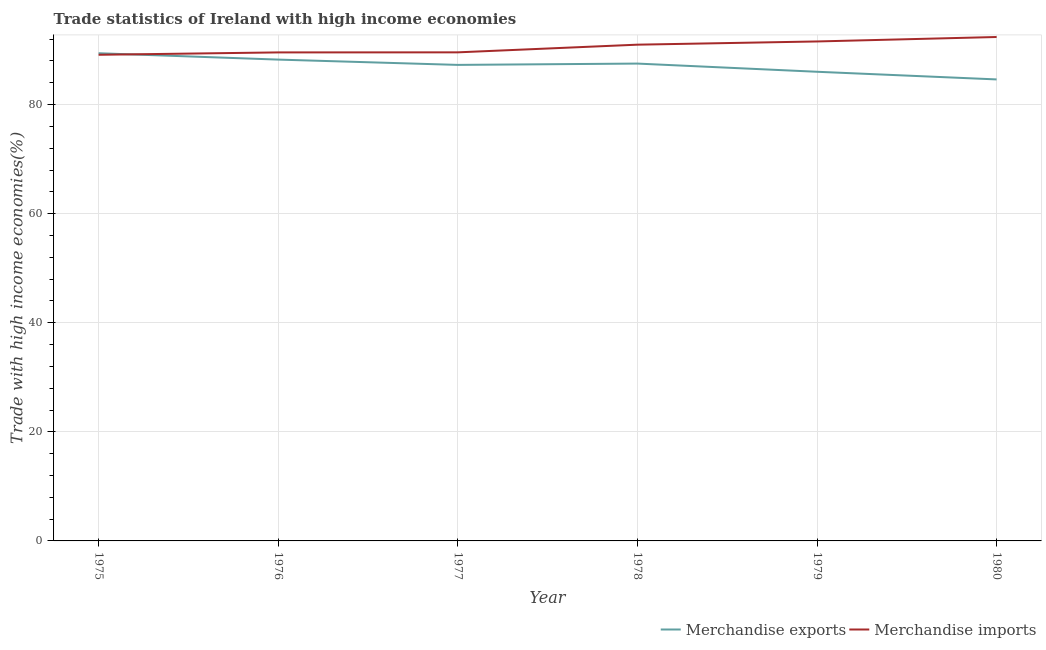How many different coloured lines are there?
Provide a short and direct response. 2. Is the number of lines equal to the number of legend labels?
Provide a succinct answer. Yes. What is the merchandise exports in 1975?
Keep it short and to the point. 89.42. Across all years, what is the maximum merchandise imports?
Keep it short and to the point. 92.4. Across all years, what is the minimum merchandise imports?
Make the answer very short. 89.13. In which year was the merchandise imports maximum?
Your response must be concise. 1980. What is the total merchandise exports in the graph?
Provide a succinct answer. 523.11. What is the difference between the merchandise exports in 1978 and that in 1980?
Provide a short and direct response. 2.91. What is the difference between the merchandise imports in 1975 and the merchandise exports in 1980?
Keep it short and to the point. 4.52. What is the average merchandise exports per year?
Offer a terse response. 87.18. In the year 1978, what is the difference between the merchandise imports and merchandise exports?
Give a very brief answer. 3.47. In how many years, is the merchandise imports greater than 8 %?
Provide a short and direct response. 6. What is the ratio of the merchandise exports in 1976 to that in 1980?
Offer a terse response. 1.04. Is the merchandise exports in 1975 less than that in 1977?
Your response must be concise. No. What is the difference between the highest and the second highest merchandise imports?
Make the answer very short. 0.82. What is the difference between the highest and the lowest merchandise exports?
Offer a terse response. 4.8. In how many years, is the merchandise exports greater than the average merchandise exports taken over all years?
Make the answer very short. 4. Is the sum of the merchandise exports in 1977 and 1979 greater than the maximum merchandise imports across all years?
Your answer should be very brief. Yes. Does the merchandise imports monotonically increase over the years?
Make the answer very short. Yes. How many lines are there?
Provide a succinct answer. 2. Are the values on the major ticks of Y-axis written in scientific E-notation?
Make the answer very short. No. Does the graph contain any zero values?
Provide a short and direct response. No. Where does the legend appear in the graph?
Give a very brief answer. Bottom right. How many legend labels are there?
Give a very brief answer. 2. What is the title of the graph?
Ensure brevity in your answer.  Trade statistics of Ireland with high income economies. Does "Death rate" appear as one of the legend labels in the graph?
Offer a terse response. No. What is the label or title of the X-axis?
Make the answer very short. Year. What is the label or title of the Y-axis?
Your answer should be very brief. Trade with high income economies(%). What is the Trade with high income economies(%) in Merchandise exports in 1975?
Keep it short and to the point. 89.42. What is the Trade with high income economies(%) in Merchandise imports in 1975?
Ensure brevity in your answer.  89.13. What is the Trade with high income economies(%) of Merchandise exports in 1976?
Your answer should be compact. 88.25. What is the Trade with high income economies(%) of Merchandise imports in 1976?
Offer a very short reply. 89.57. What is the Trade with high income economies(%) of Merchandise exports in 1977?
Your response must be concise. 87.28. What is the Trade with high income economies(%) in Merchandise imports in 1977?
Offer a very short reply. 89.58. What is the Trade with high income economies(%) of Merchandise exports in 1978?
Provide a short and direct response. 87.52. What is the Trade with high income economies(%) in Merchandise imports in 1978?
Provide a short and direct response. 90.99. What is the Trade with high income economies(%) in Merchandise exports in 1979?
Give a very brief answer. 86.02. What is the Trade with high income economies(%) in Merchandise imports in 1979?
Provide a succinct answer. 91.58. What is the Trade with high income economies(%) of Merchandise exports in 1980?
Offer a very short reply. 84.62. What is the Trade with high income economies(%) in Merchandise imports in 1980?
Offer a very short reply. 92.4. Across all years, what is the maximum Trade with high income economies(%) of Merchandise exports?
Ensure brevity in your answer.  89.42. Across all years, what is the maximum Trade with high income economies(%) of Merchandise imports?
Provide a short and direct response. 92.4. Across all years, what is the minimum Trade with high income economies(%) in Merchandise exports?
Give a very brief answer. 84.62. Across all years, what is the minimum Trade with high income economies(%) in Merchandise imports?
Your response must be concise. 89.13. What is the total Trade with high income economies(%) of Merchandise exports in the graph?
Keep it short and to the point. 523.11. What is the total Trade with high income economies(%) of Merchandise imports in the graph?
Offer a very short reply. 543.24. What is the difference between the Trade with high income economies(%) in Merchandise exports in 1975 and that in 1976?
Your answer should be very brief. 1.16. What is the difference between the Trade with high income economies(%) of Merchandise imports in 1975 and that in 1976?
Your answer should be very brief. -0.44. What is the difference between the Trade with high income economies(%) in Merchandise exports in 1975 and that in 1977?
Your answer should be very brief. 2.14. What is the difference between the Trade with high income economies(%) of Merchandise imports in 1975 and that in 1977?
Provide a short and direct response. -0.45. What is the difference between the Trade with high income economies(%) in Merchandise exports in 1975 and that in 1978?
Offer a very short reply. 1.9. What is the difference between the Trade with high income economies(%) of Merchandise imports in 1975 and that in 1978?
Give a very brief answer. -1.86. What is the difference between the Trade with high income economies(%) in Merchandise exports in 1975 and that in 1979?
Your answer should be compact. 3.4. What is the difference between the Trade with high income economies(%) of Merchandise imports in 1975 and that in 1979?
Your answer should be compact. -2.44. What is the difference between the Trade with high income economies(%) in Merchandise exports in 1975 and that in 1980?
Give a very brief answer. 4.8. What is the difference between the Trade with high income economies(%) in Merchandise imports in 1975 and that in 1980?
Make the answer very short. -3.26. What is the difference between the Trade with high income economies(%) of Merchandise exports in 1976 and that in 1977?
Provide a short and direct response. 0.97. What is the difference between the Trade with high income economies(%) in Merchandise imports in 1976 and that in 1977?
Provide a succinct answer. -0.01. What is the difference between the Trade with high income economies(%) of Merchandise exports in 1976 and that in 1978?
Provide a succinct answer. 0.73. What is the difference between the Trade with high income economies(%) in Merchandise imports in 1976 and that in 1978?
Keep it short and to the point. -1.42. What is the difference between the Trade with high income economies(%) in Merchandise exports in 1976 and that in 1979?
Your answer should be compact. 2.23. What is the difference between the Trade with high income economies(%) of Merchandise imports in 1976 and that in 1979?
Your answer should be compact. -2.01. What is the difference between the Trade with high income economies(%) of Merchandise exports in 1976 and that in 1980?
Your answer should be very brief. 3.64. What is the difference between the Trade with high income economies(%) of Merchandise imports in 1976 and that in 1980?
Offer a very short reply. -2.83. What is the difference between the Trade with high income economies(%) in Merchandise exports in 1977 and that in 1978?
Ensure brevity in your answer.  -0.24. What is the difference between the Trade with high income economies(%) of Merchandise imports in 1977 and that in 1978?
Provide a short and direct response. -1.41. What is the difference between the Trade with high income economies(%) of Merchandise exports in 1977 and that in 1979?
Your answer should be compact. 1.26. What is the difference between the Trade with high income economies(%) of Merchandise imports in 1977 and that in 1979?
Offer a terse response. -2. What is the difference between the Trade with high income economies(%) in Merchandise exports in 1977 and that in 1980?
Make the answer very short. 2.66. What is the difference between the Trade with high income economies(%) of Merchandise imports in 1977 and that in 1980?
Ensure brevity in your answer.  -2.81. What is the difference between the Trade with high income economies(%) of Merchandise exports in 1978 and that in 1979?
Offer a very short reply. 1.5. What is the difference between the Trade with high income economies(%) in Merchandise imports in 1978 and that in 1979?
Make the answer very short. -0.59. What is the difference between the Trade with high income economies(%) in Merchandise exports in 1978 and that in 1980?
Give a very brief answer. 2.91. What is the difference between the Trade with high income economies(%) of Merchandise imports in 1978 and that in 1980?
Offer a very short reply. -1.41. What is the difference between the Trade with high income economies(%) of Merchandise exports in 1979 and that in 1980?
Provide a short and direct response. 1.41. What is the difference between the Trade with high income economies(%) in Merchandise imports in 1979 and that in 1980?
Make the answer very short. -0.82. What is the difference between the Trade with high income economies(%) in Merchandise exports in 1975 and the Trade with high income economies(%) in Merchandise imports in 1976?
Your answer should be compact. -0.15. What is the difference between the Trade with high income economies(%) in Merchandise exports in 1975 and the Trade with high income economies(%) in Merchandise imports in 1977?
Provide a short and direct response. -0.16. What is the difference between the Trade with high income economies(%) in Merchandise exports in 1975 and the Trade with high income economies(%) in Merchandise imports in 1978?
Give a very brief answer. -1.57. What is the difference between the Trade with high income economies(%) in Merchandise exports in 1975 and the Trade with high income economies(%) in Merchandise imports in 1979?
Your response must be concise. -2.16. What is the difference between the Trade with high income economies(%) of Merchandise exports in 1975 and the Trade with high income economies(%) of Merchandise imports in 1980?
Make the answer very short. -2.98. What is the difference between the Trade with high income economies(%) of Merchandise exports in 1976 and the Trade with high income economies(%) of Merchandise imports in 1977?
Provide a short and direct response. -1.33. What is the difference between the Trade with high income economies(%) of Merchandise exports in 1976 and the Trade with high income economies(%) of Merchandise imports in 1978?
Keep it short and to the point. -2.74. What is the difference between the Trade with high income economies(%) in Merchandise exports in 1976 and the Trade with high income economies(%) in Merchandise imports in 1979?
Ensure brevity in your answer.  -3.32. What is the difference between the Trade with high income economies(%) in Merchandise exports in 1976 and the Trade with high income economies(%) in Merchandise imports in 1980?
Make the answer very short. -4.14. What is the difference between the Trade with high income economies(%) of Merchandise exports in 1977 and the Trade with high income economies(%) of Merchandise imports in 1978?
Make the answer very short. -3.71. What is the difference between the Trade with high income economies(%) in Merchandise exports in 1977 and the Trade with high income economies(%) in Merchandise imports in 1979?
Make the answer very short. -4.3. What is the difference between the Trade with high income economies(%) of Merchandise exports in 1977 and the Trade with high income economies(%) of Merchandise imports in 1980?
Offer a very short reply. -5.12. What is the difference between the Trade with high income economies(%) in Merchandise exports in 1978 and the Trade with high income economies(%) in Merchandise imports in 1979?
Offer a terse response. -4.06. What is the difference between the Trade with high income economies(%) of Merchandise exports in 1978 and the Trade with high income economies(%) of Merchandise imports in 1980?
Ensure brevity in your answer.  -4.87. What is the difference between the Trade with high income economies(%) in Merchandise exports in 1979 and the Trade with high income economies(%) in Merchandise imports in 1980?
Make the answer very short. -6.37. What is the average Trade with high income economies(%) in Merchandise exports per year?
Your response must be concise. 87.18. What is the average Trade with high income economies(%) of Merchandise imports per year?
Your answer should be compact. 90.54. In the year 1975, what is the difference between the Trade with high income economies(%) of Merchandise exports and Trade with high income economies(%) of Merchandise imports?
Offer a very short reply. 0.28. In the year 1976, what is the difference between the Trade with high income economies(%) of Merchandise exports and Trade with high income economies(%) of Merchandise imports?
Make the answer very short. -1.32. In the year 1977, what is the difference between the Trade with high income economies(%) in Merchandise exports and Trade with high income economies(%) in Merchandise imports?
Keep it short and to the point. -2.3. In the year 1978, what is the difference between the Trade with high income economies(%) of Merchandise exports and Trade with high income economies(%) of Merchandise imports?
Your response must be concise. -3.47. In the year 1979, what is the difference between the Trade with high income economies(%) in Merchandise exports and Trade with high income economies(%) in Merchandise imports?
Offer a very short reply. -5.56. In the year 1980, what is the difference between the Trade with high income economies(%) of Merchandise exports and Trade with high income economies(%) of Merchandise imports?
Your answer should be very brief. -7.78. What is the ratio of the Trade with high income economies(%) of Merchandise exports in 1975 to that in 1976?
Your response must be concise. 1.01. What is the ratio of the Trade with high income economies(%) in Merchandise exports in 1975 to that in 1977?
Keep it short and to the point. 1.02. What is the ratio of the Trade with high income economies(%) in Merchandise exports in 1975 to that in 1978?
Make the answer very short. 1.02. What is the ratio of the Trade with high income economies(%) in Merchandise imports in 1975 to that in 1978?
Your answer should be very brief. 0.98. What is the ratio of the Trade with high income economies(%) of Merchandise exports in 1975 to that in 1979?
Your answer should be very brief. 1.04. What is the ratio of the Trade with high income economies(%) of Merchandise imports in 1975 to that in 1979?
Offer a terse response. 0.97. What is the ratio of the Trade with high income economies(%) in Merchandise exports in 1975 to that in 1980?
Keep it short and to the point. 1.06. What is the ratio of the Trade with high income economies(%) of Merchandise imports in 1975 to that in 1980?
Your answer should be compact. 0.96. What is the ratio of the Trade with high income economies(%) in Merchandise exports in 1976 to that in 1977?
Ensure brevity in your answer.  1.01. What is the ratio of the Trade with high income economies(%) of Merchandise exports in 1976 to that in 1978?
Provide a succinct answer. 1.01. What is the ratio of the Trade with high income economies(%) in Merchandise imports in 1976 to that in 1978?
Provide a succinct answer. 0.98. What is the ratio of the Trade with high income economies(%) of Merchandise exports in 1976 to that in 1979?
Make the answer very short. 1.03. What is the ratio of the Trade with high income economies(%) of Merchandise imports in 1976 to that in 1979?
Your answer should be compact. 0.98. What is the ratio of the Trade with high income economies(%) in Merchandise exports in 1976 to that in 1980?
Ensure brevity in your answer.  1.04. What is the ratio of the Trade with high income economies(%) in Merchandise imports in 1976 to that in 1980?
Offer a terse response. 0.97. What is the ratio of the Trade with high income economies(%) in Merchandise exports in 1977 to that in 1978?
Offer a very short reply. 1. What is the ratio of the Trade with high income economies(%) of Merchandise imports in 1977 to that in 1978?
Make the answer very short. 0.98. What is the ratio of the Trade with high income economies(%) of Merchandise exports in 1977 to that in 1979?
Offer a very short reply. 1.01. What is the ratio of the Trade with high income economies(%) of Merchandise imports in 1977 to that in 1979?
Offer a terse response. 0.98. What is the ratio of the Trade with high income economies(%) in Merchandise exports in 1977 to that in 1980?
Give a very brief answer. 1.03. What is the ratio of the Trade with high income economies(%) in Merchandise imports in 1977 to that in 1980?
Give a very brief answer. 0.97. What is the ratio of the Trade with high income economies(%) of Merchandise exports in 1978 to that in 1979?
Your answer should be compact. 1.02. What is the ratio of the Trade with high income economies(%) in Merchandise imports in 1978 to that in 1979?
Offer a terse response. 0.99. What is the ratio of the Trade with high income economies(%) in Merchandise exports in 1978 to that in 1980?
Your response must be concise. 1.03. What is the ratio of the Trade with high income economies(%) of Merchandise exports in 1979 to that in 1980?
Keep it short and to the point. 1.02. What is the ratio of the Trade with high income economies(%) in Merchandise imports in 1979 to that in 1980?
Offer a terse response. 0.99. What is the difference between the highest and the second highest Trade with high income economies(%) in Merchandise exports?
Offer a terse response. 1.16. What is the difference between the highest and the second highest Trade with high income economies(%) in Merchandise imports?
Keep it short and to the point. 0.82. What is the difference between the highest and the lowest Trade with high income economies(%) in Merchandise exports?
Offer a very short reply. 4.8. What is the difference between the highest and the lowest Trade with high income economies(%) of Merchandise imports?
Give a very brief answer. 3.26. 